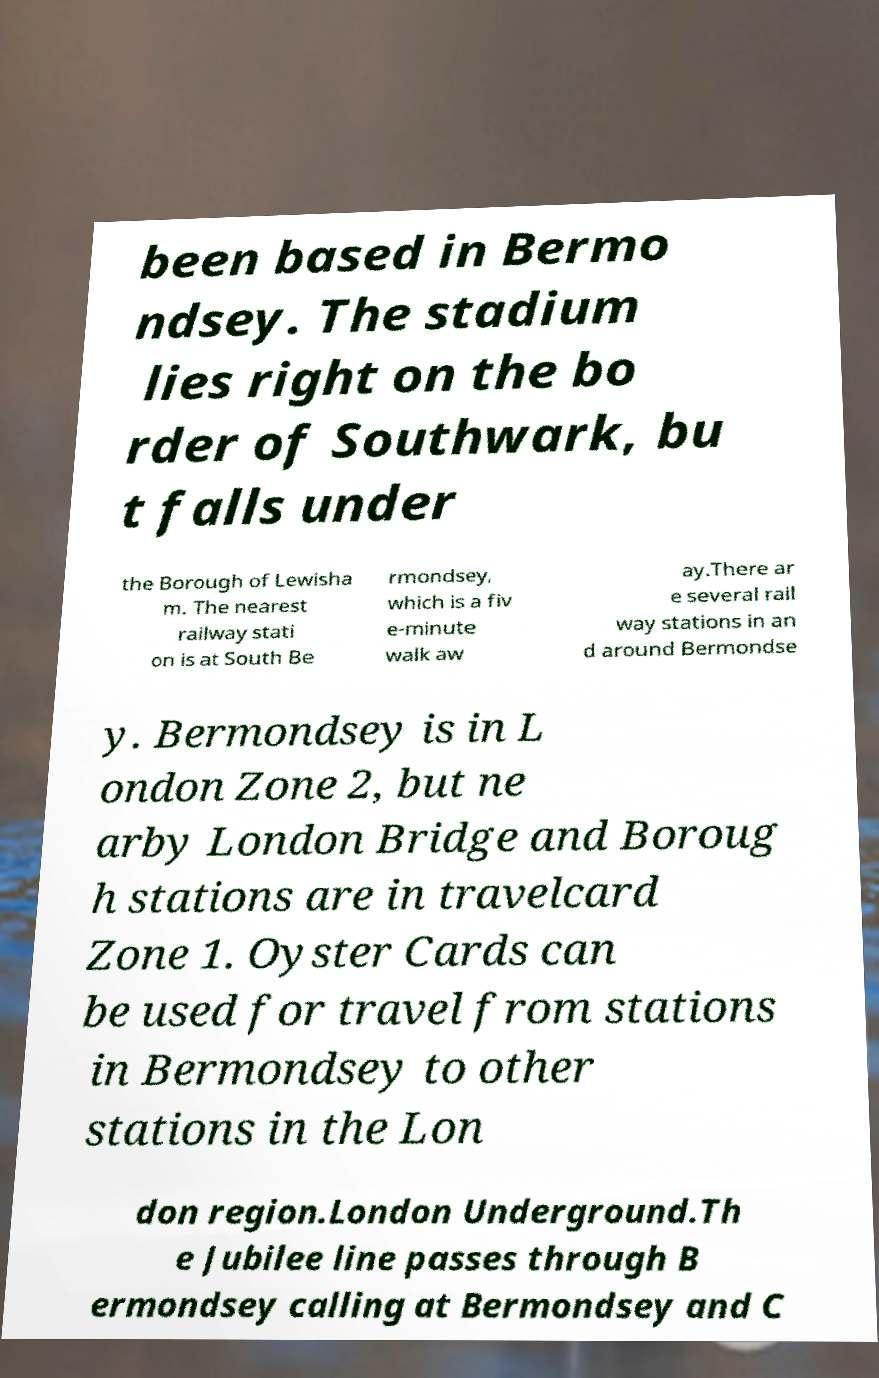What messages or text are displayed in this image? I need them in a readable, typed format. been based in Bermo ndsey. The stadium lies right on the bo rder of Southwark, bu t falls under the Borough of Lewisha m. The nearest railway stati on is at South Be rmondsey, which is a fiv e-minute walk aw ay.There ar e several rail way stations in an d around Bermondse y. Bermondsey is in L ondon Zone 2, but ne arby London Bridge and Boroug h stations are in travelcard Zone 1. Oyster Cards can be used for travel from stations in Bermondsey to other stations in the Lon don region.London Underground.Th e Jubilee line passes through B ermondsey calling at Bermondsey and C 